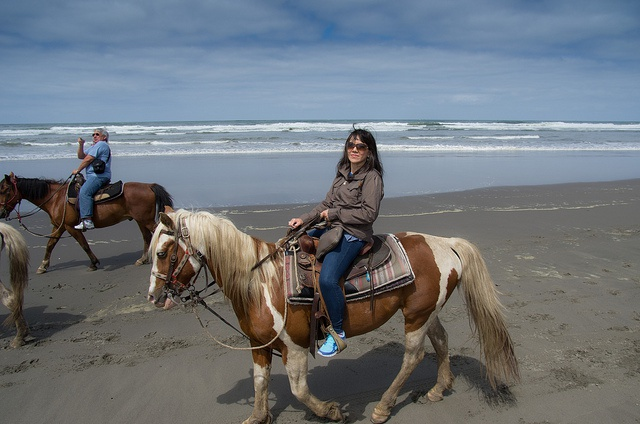Describe the objects in this image and their specific colors. I can see horse in gray, black, and maroon tones, people in gray, black, and navy tones, horse in gray, black, and maroon tones, horse in gray and black tones, and people in gray, black, and blue tones in this image. 